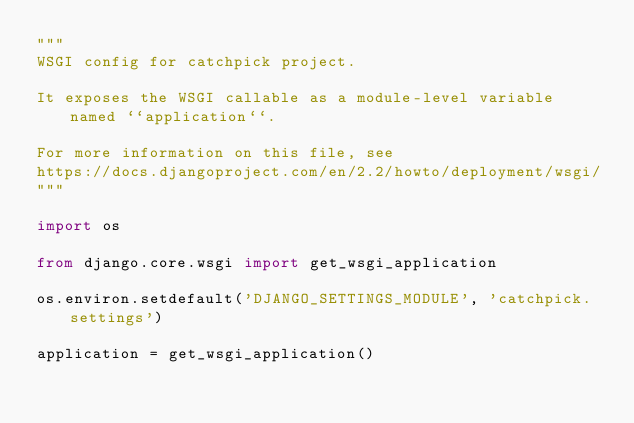<code> <loc_0><loc_0><loc_500><loc_500><_Python_>"""
WSGI config for catchpick project.

It exposes the WSGI callable as a module-level variable named ``application``.

For more information on this file, see
https://docs.djangoproject.com/en/2.2/howto/deployment/wsgi/
"""

import os

from django.core.wsgi import get_wsgi_application

os.environ.setdefault('DJANGO_SETTINGS_MODULE', 'catchpick.settings')

application = get_wsgi_application()
</code> 